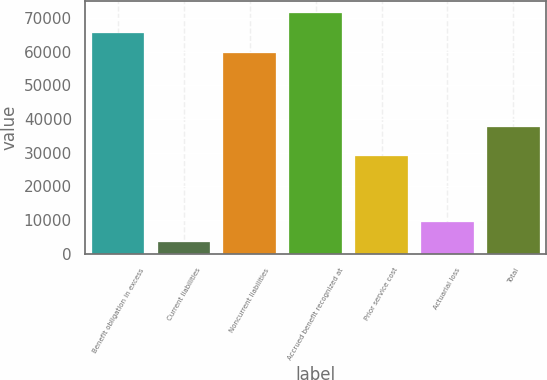<chart> <loc_0><loc_0><loc_500><loc_500><bar_chart><fcel>Benefit obligation in excess<fcel>Current liabilities<fcel>Noncurrent liabilities<fcel>Accrued benefit recognized at<fcel>Prior service cost<fcel>Actuarial loss<fcel>Total<nl><fcel>65605.1<fcel>3586<fcel>59641<fcel>71569.2<fcel>28897<fcel>9550.1<fcel>37505<nl></chart> 